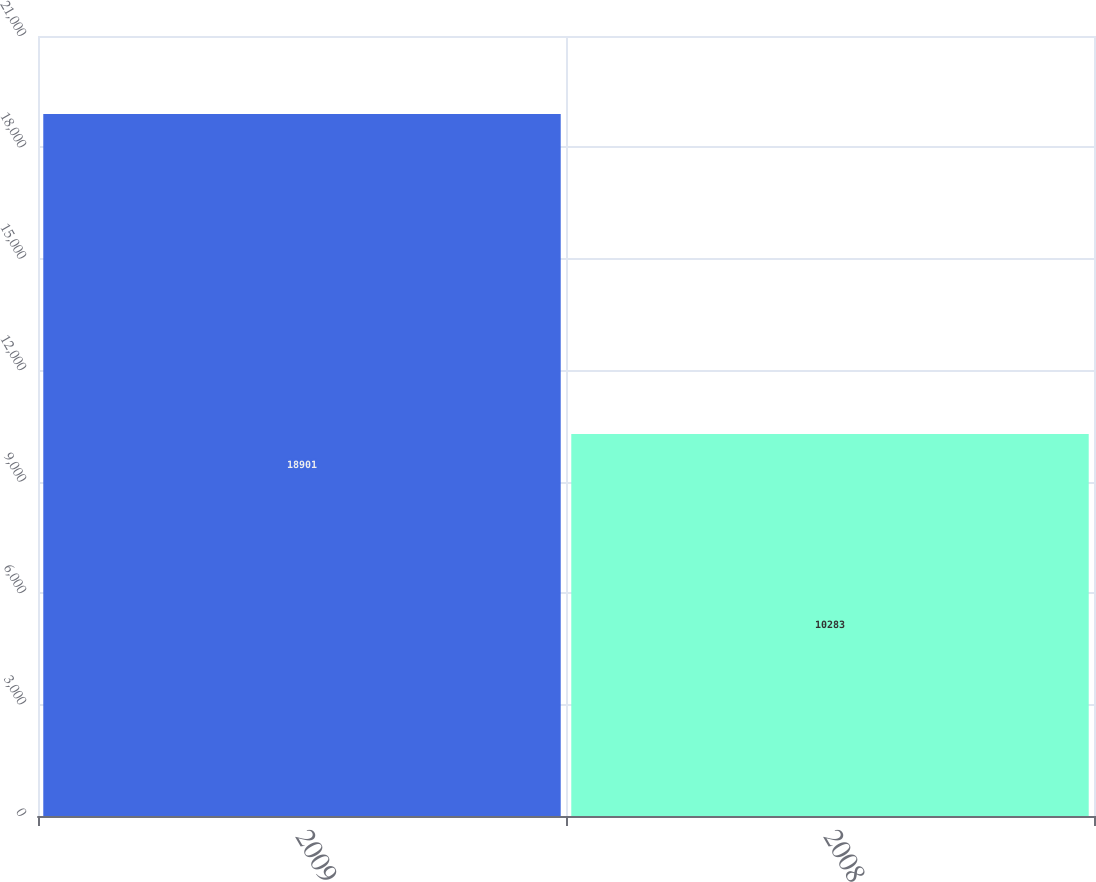<chart> <loc_0><loc_0><loc_500><loc_500><bar_chart><fcel>2009<fcel>2008<nl><fcel>18901<fcel>10283<nl></chart> 